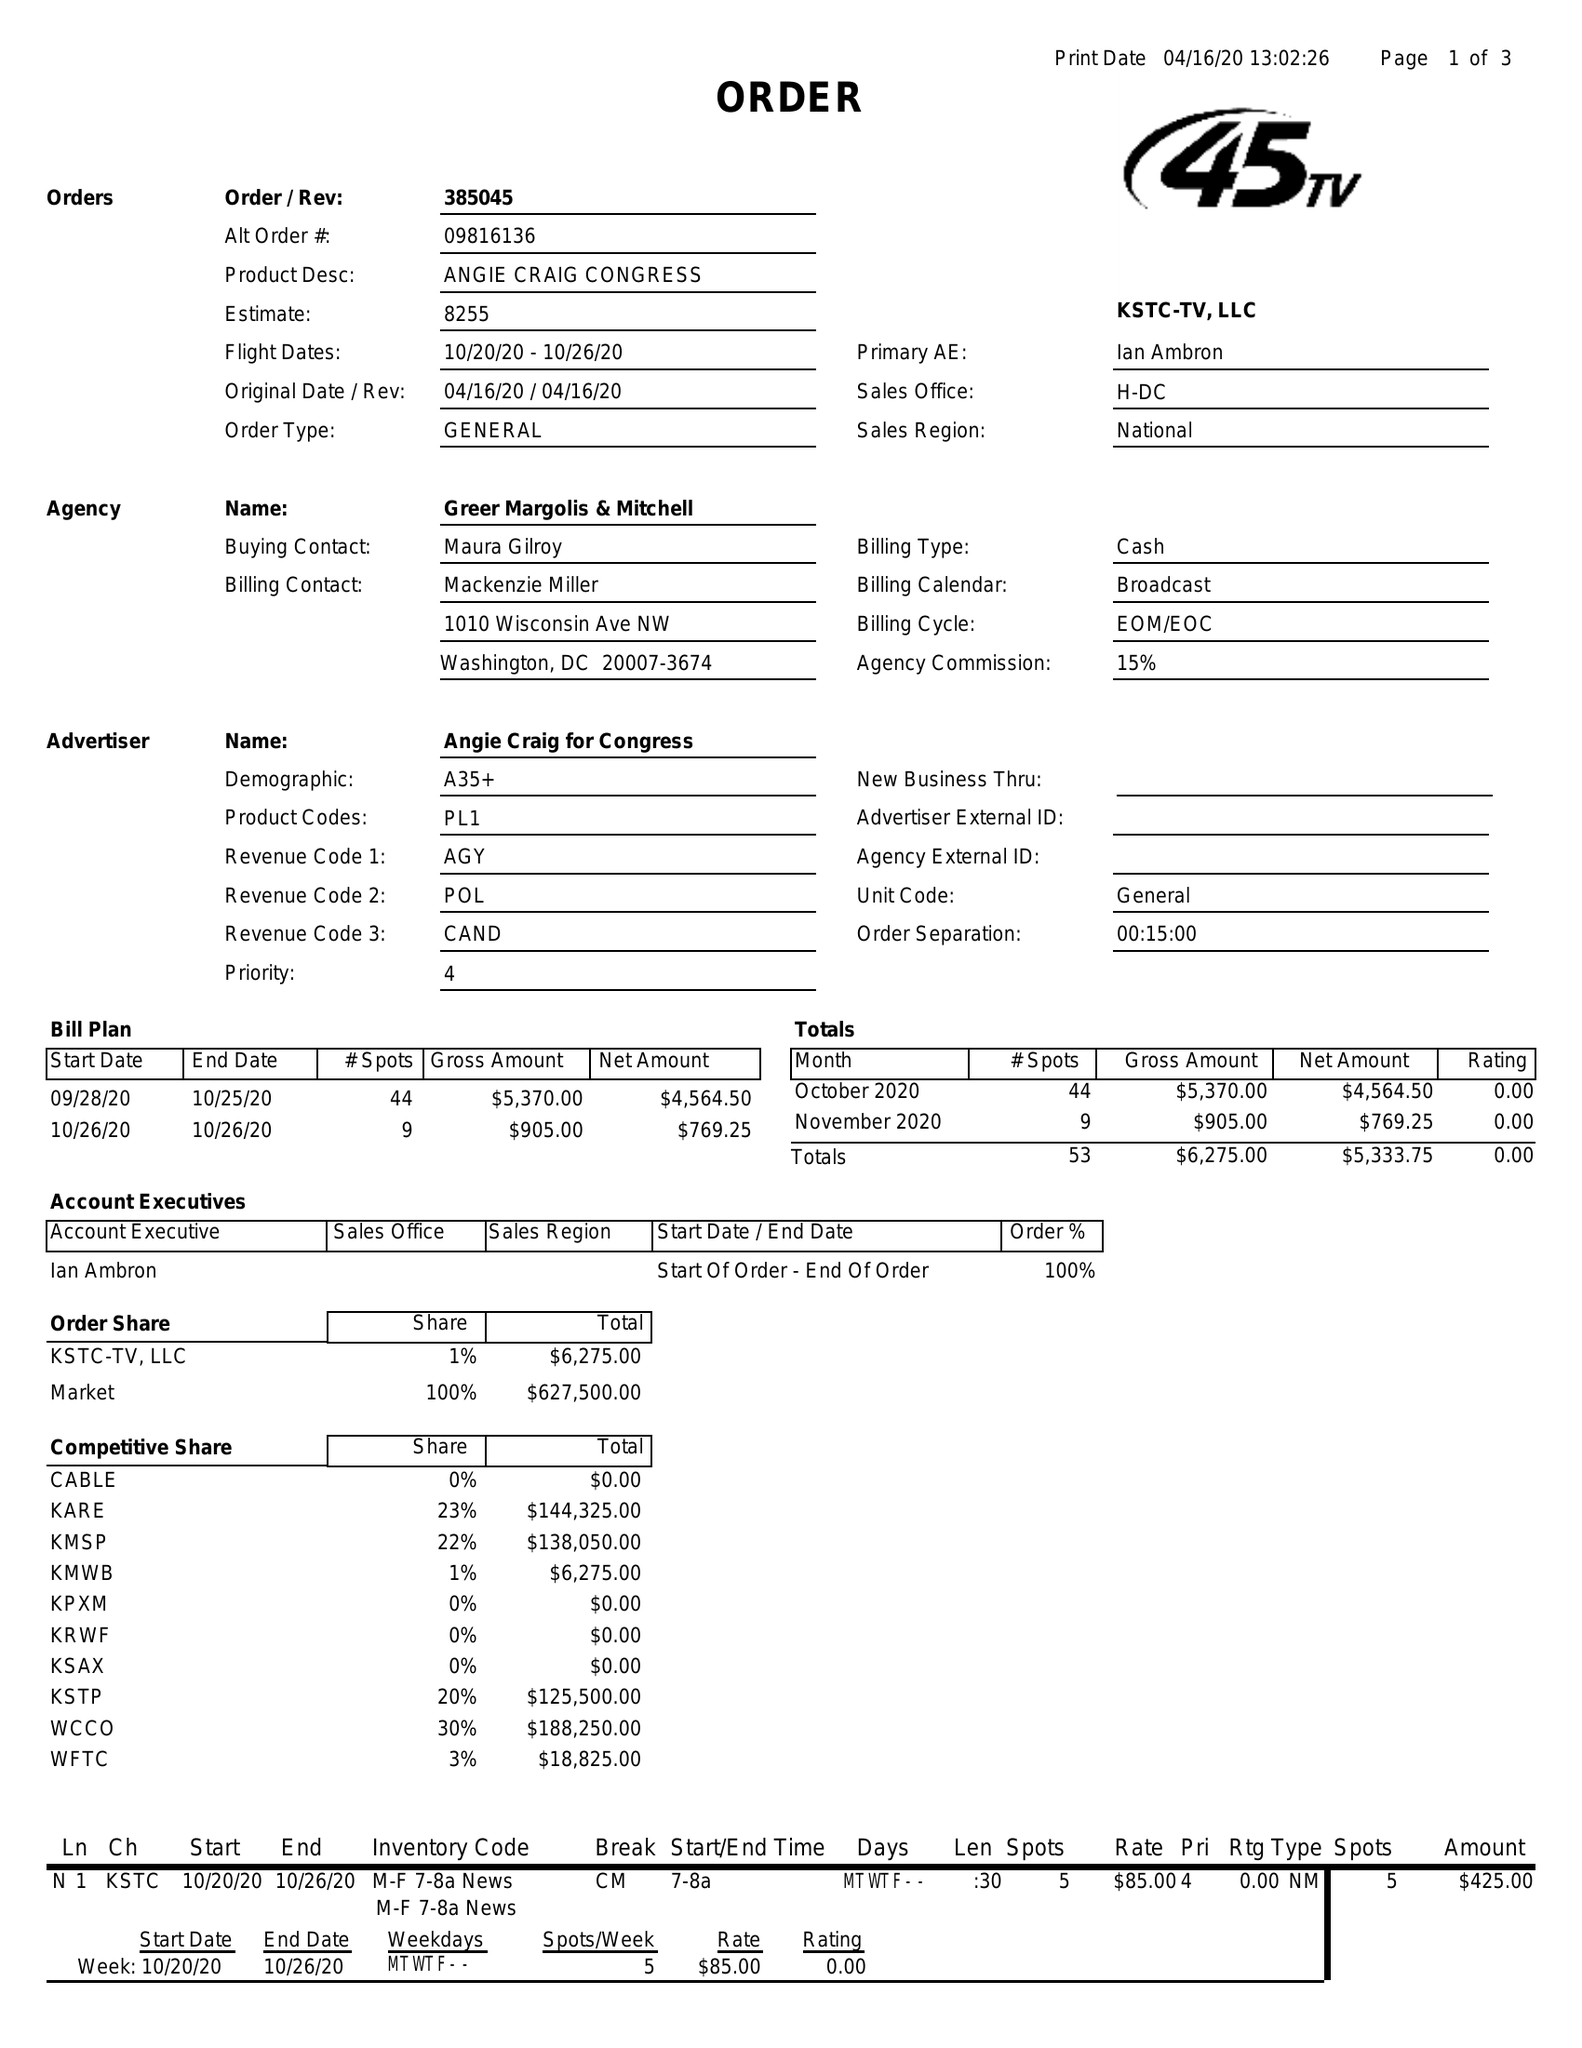What is the value for the contract_num?
Answer the question using a single word or phrase. 385045 